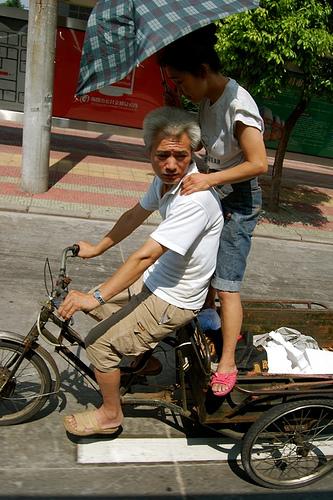What is on the girl's feet?
Write a very short answer. Sandals. What kind of bike is this?
Answer briefly. Tricycle. Do these people know each other?
Quick response, please. Yes. What is the man riding on?
Quick response, please. Tricycle. 